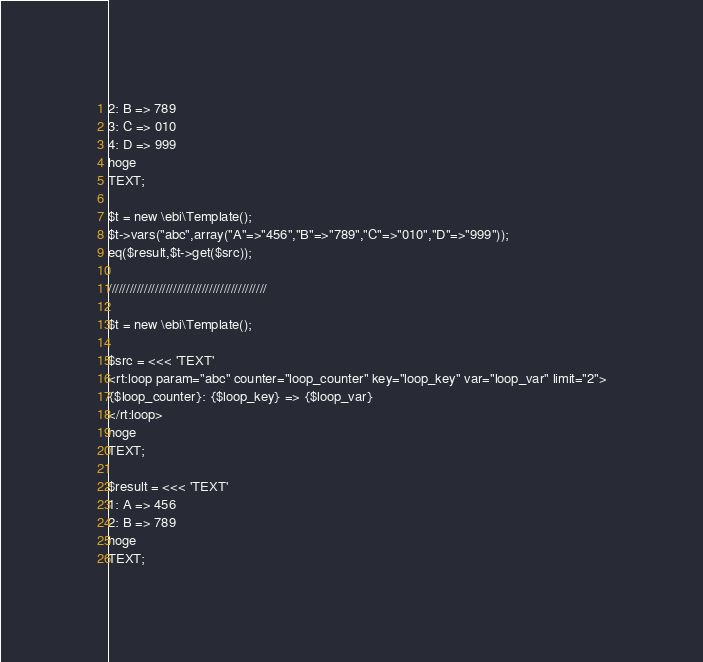<code> <loc_0><loc_0><loc_500><loc_500><_PHP_>2: B => 789
3: C => 010
4: D => 999
hoge
TEXT;

$t = new \ebi\Template();
$t->vars("abc",array("A"=>"456","B"=>"789","C"=>"010","D"=>"999"));
eq($result,$t->get($src));

////////////////////////////////////////////

$t = new \ebi\Template();

$src = <<< 'TEXT'
<rt:loop param="abc" counter="loop_counter" key="loop_key" var="loop_var" limit="2">
{$loop_counter}: {$loop_key} => {$loop_var}
</rt:loop>
hoge
TEXT;

$result = <<< 'TEXT'
1: A => 456
2: B => 789
hoge
TEXT;
</code> 